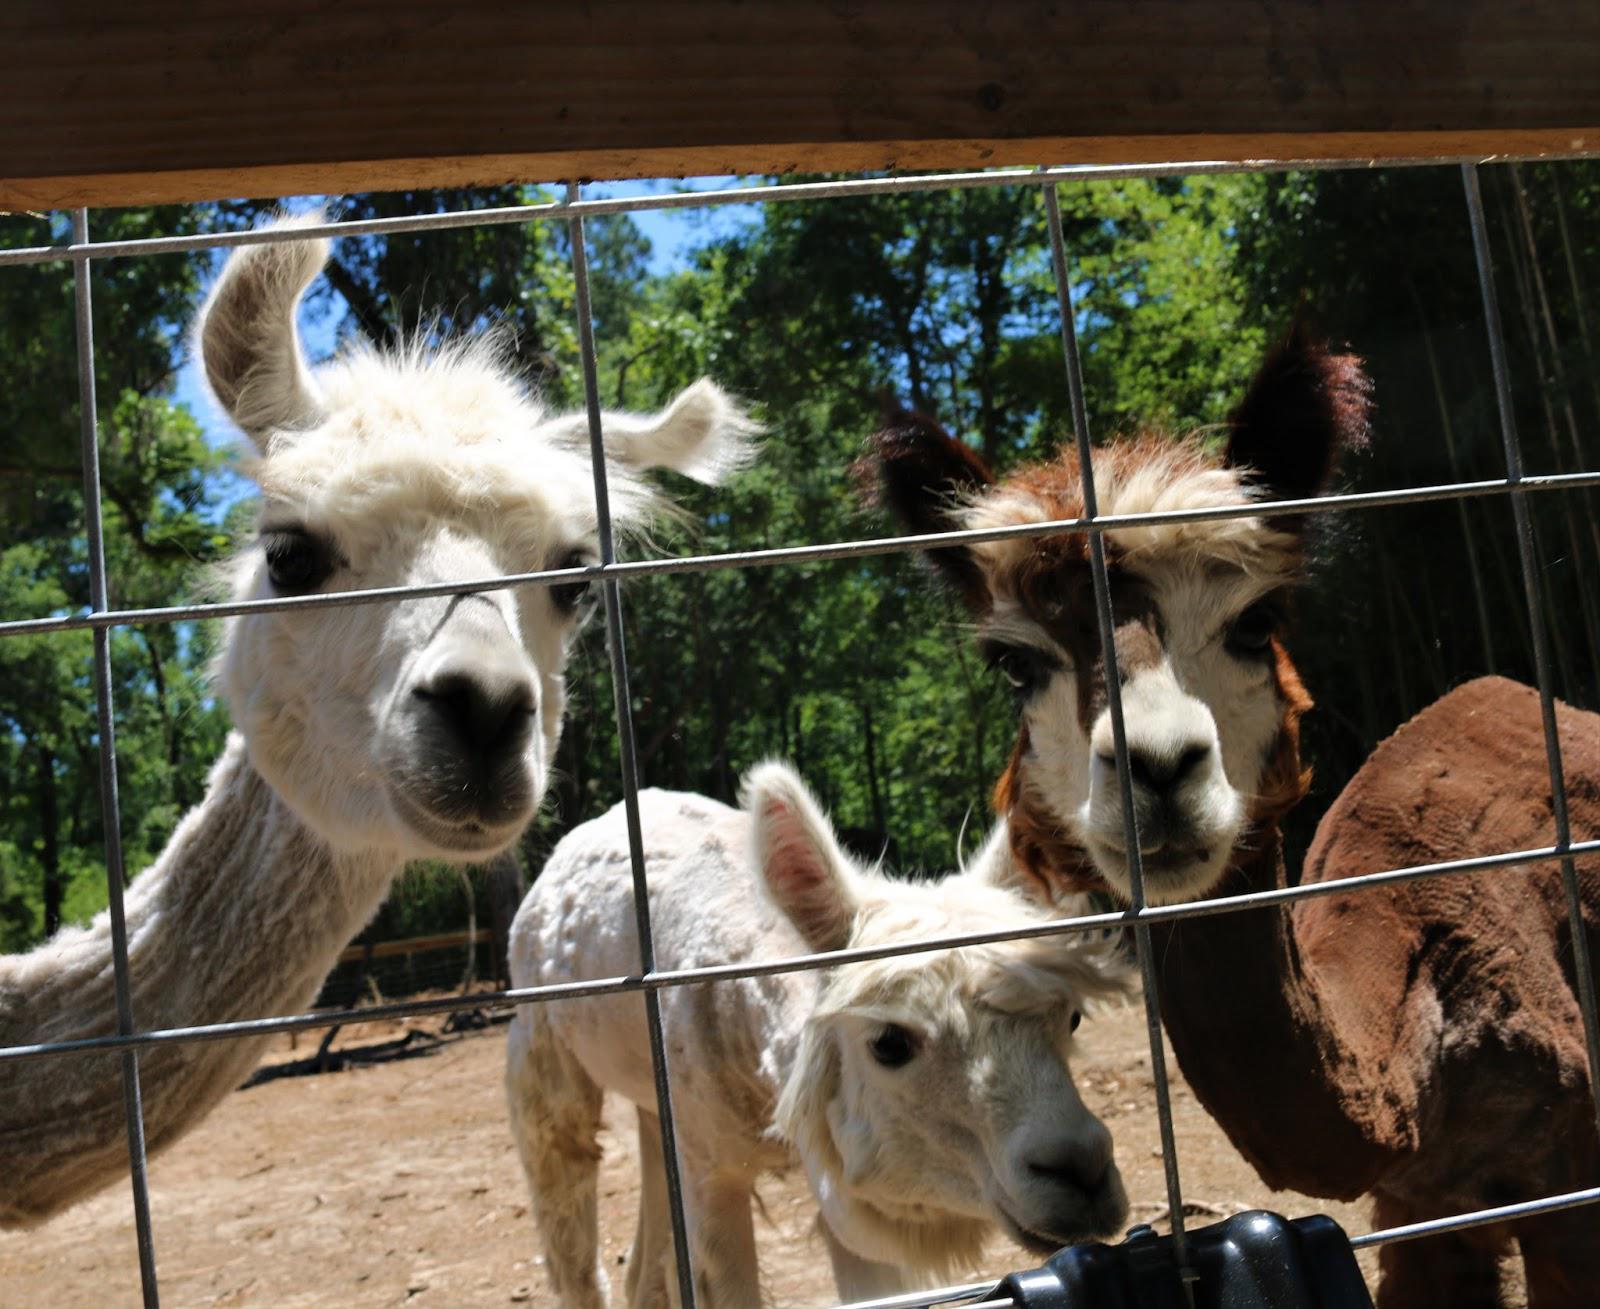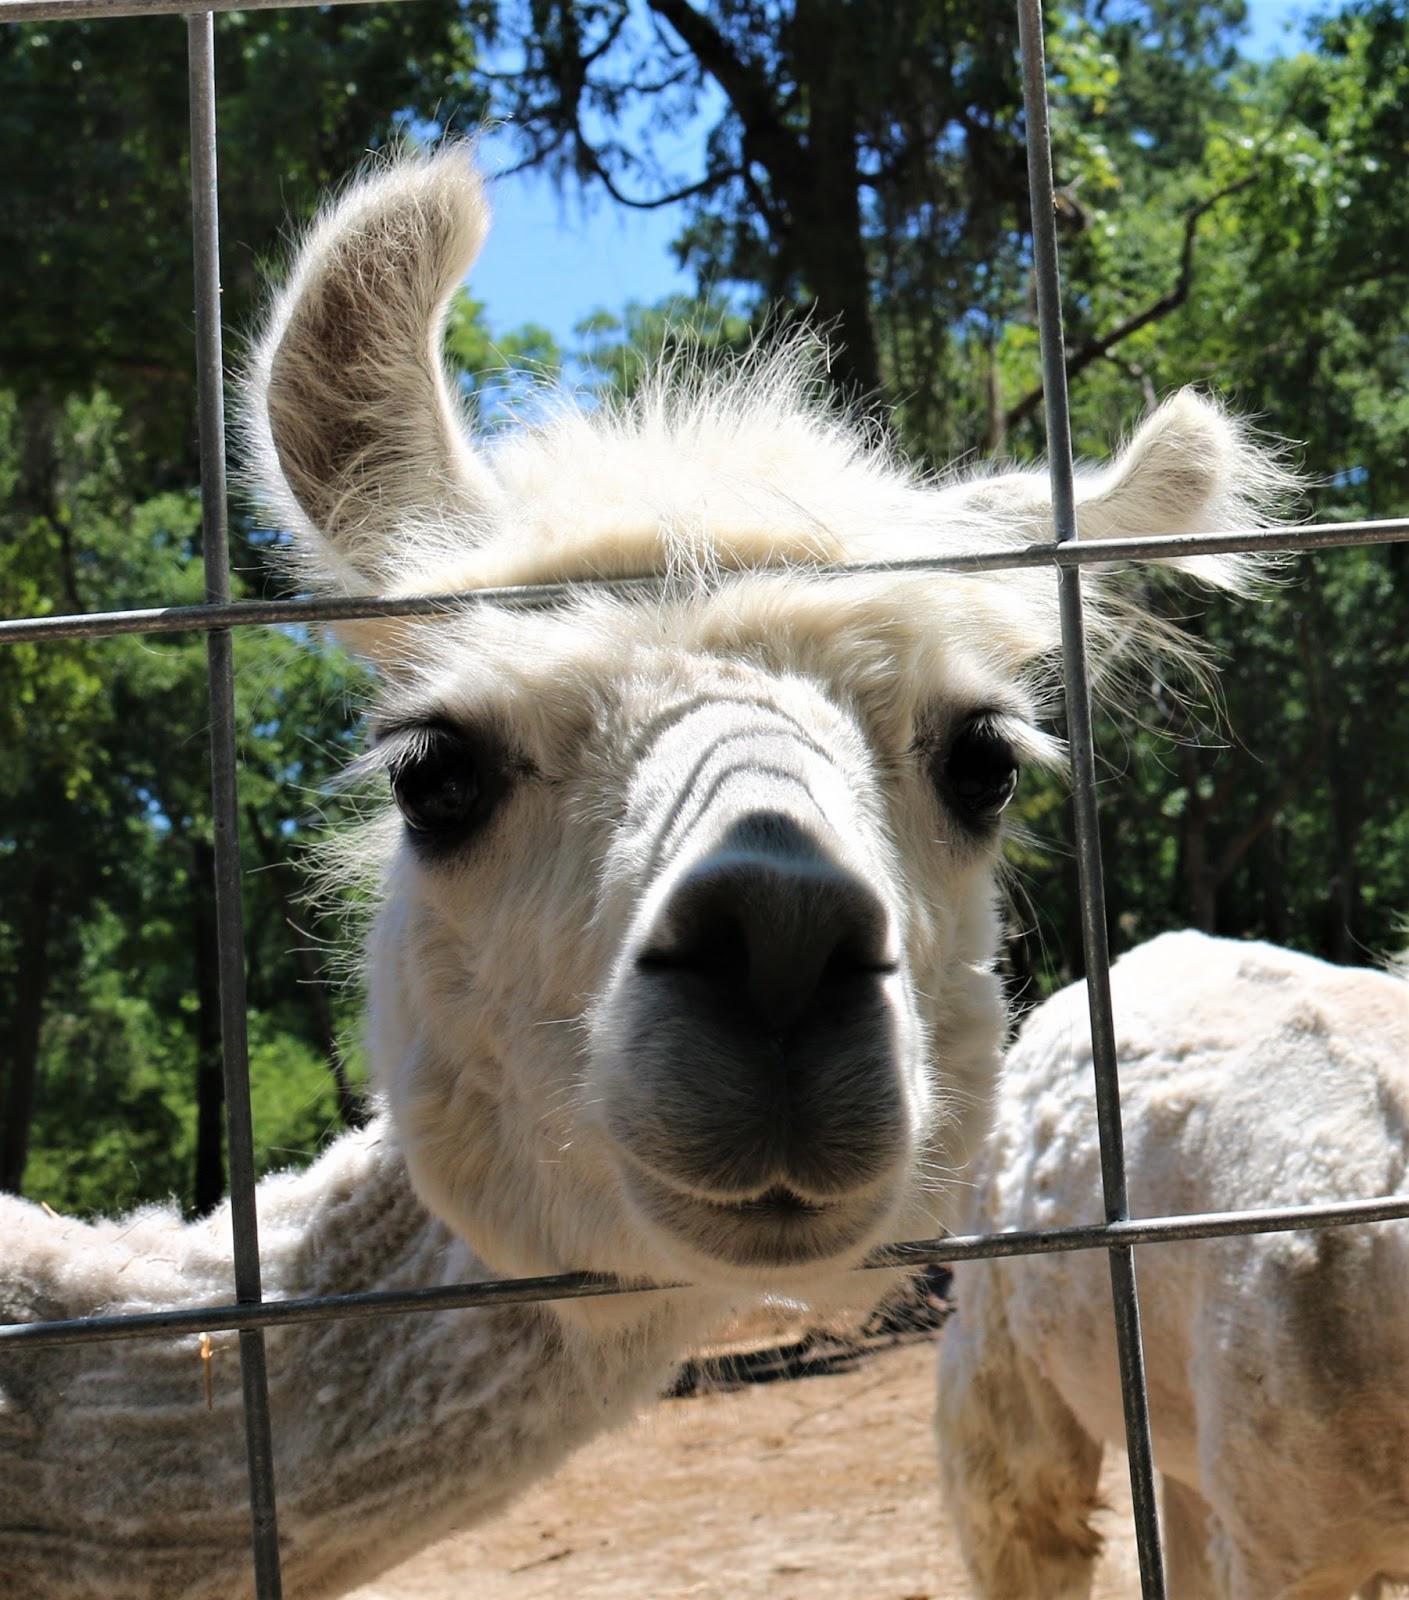The first image is the image on the left, the second image is the image on the right. Analyze the images presented: Is the assertion "There are children feeding a llama." valid? Answer yes or no. No. The first image is the image on the left, the second image is the image on the right. Evaluate the accuracy of this statement regarding the images: "In one image, multiple children are standing in front of at least one llama, with their hands outstretched to feed it.". Is it true? Answer yes or no. No. 